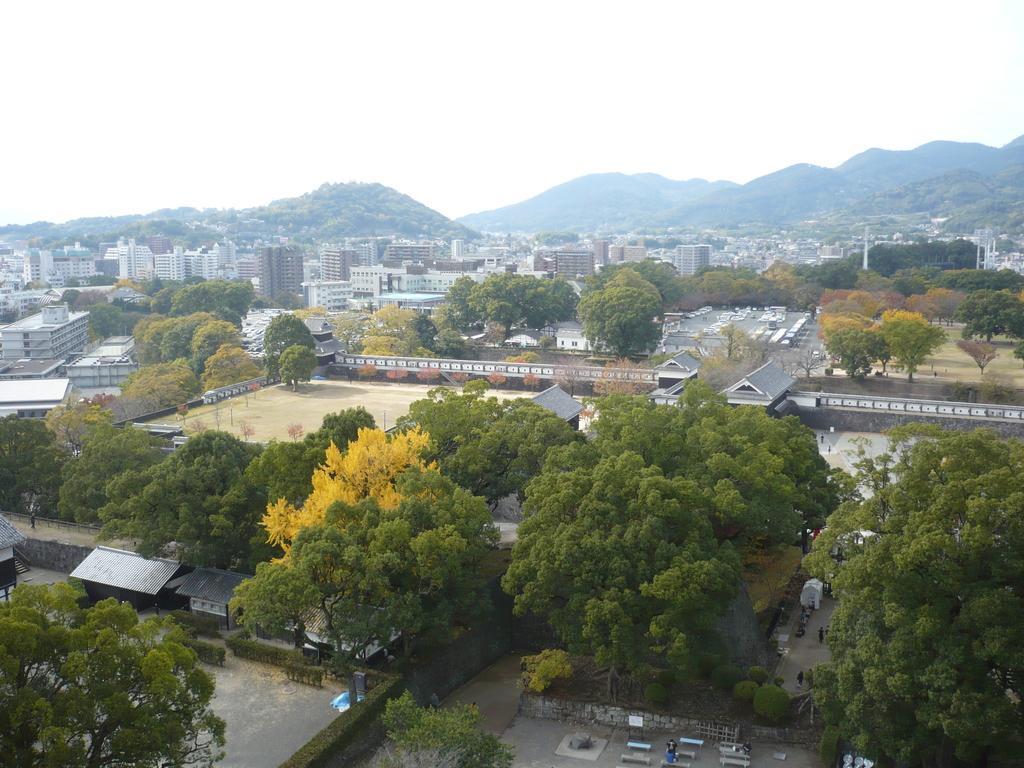What objects are in the foreground of the image? There are shutters, benches, and trees in the foreground of the image. What structures can be seen in the middle of the image? There are buildings and trees in the middle of the image. What is visible at the top of the image? The sky is visible at the top of the image. Can you see any pipes in the image? There are no pipes visible in the image. Are there any ants fighting in the image? There are no ants or any fighting depicted in the image. 